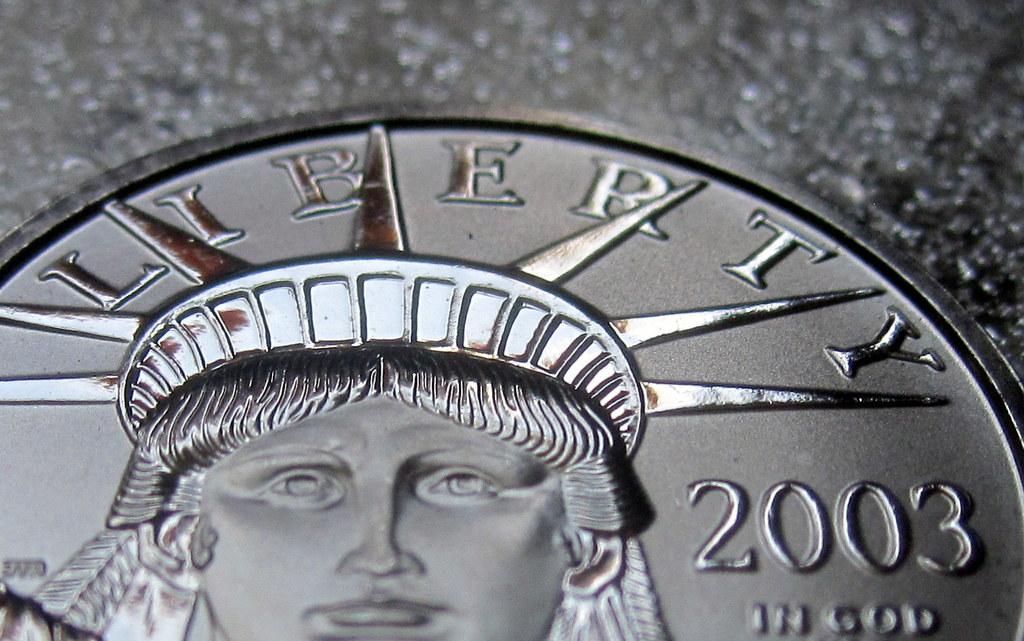What year was the coin minted?
Your response must be concise. 2003. 